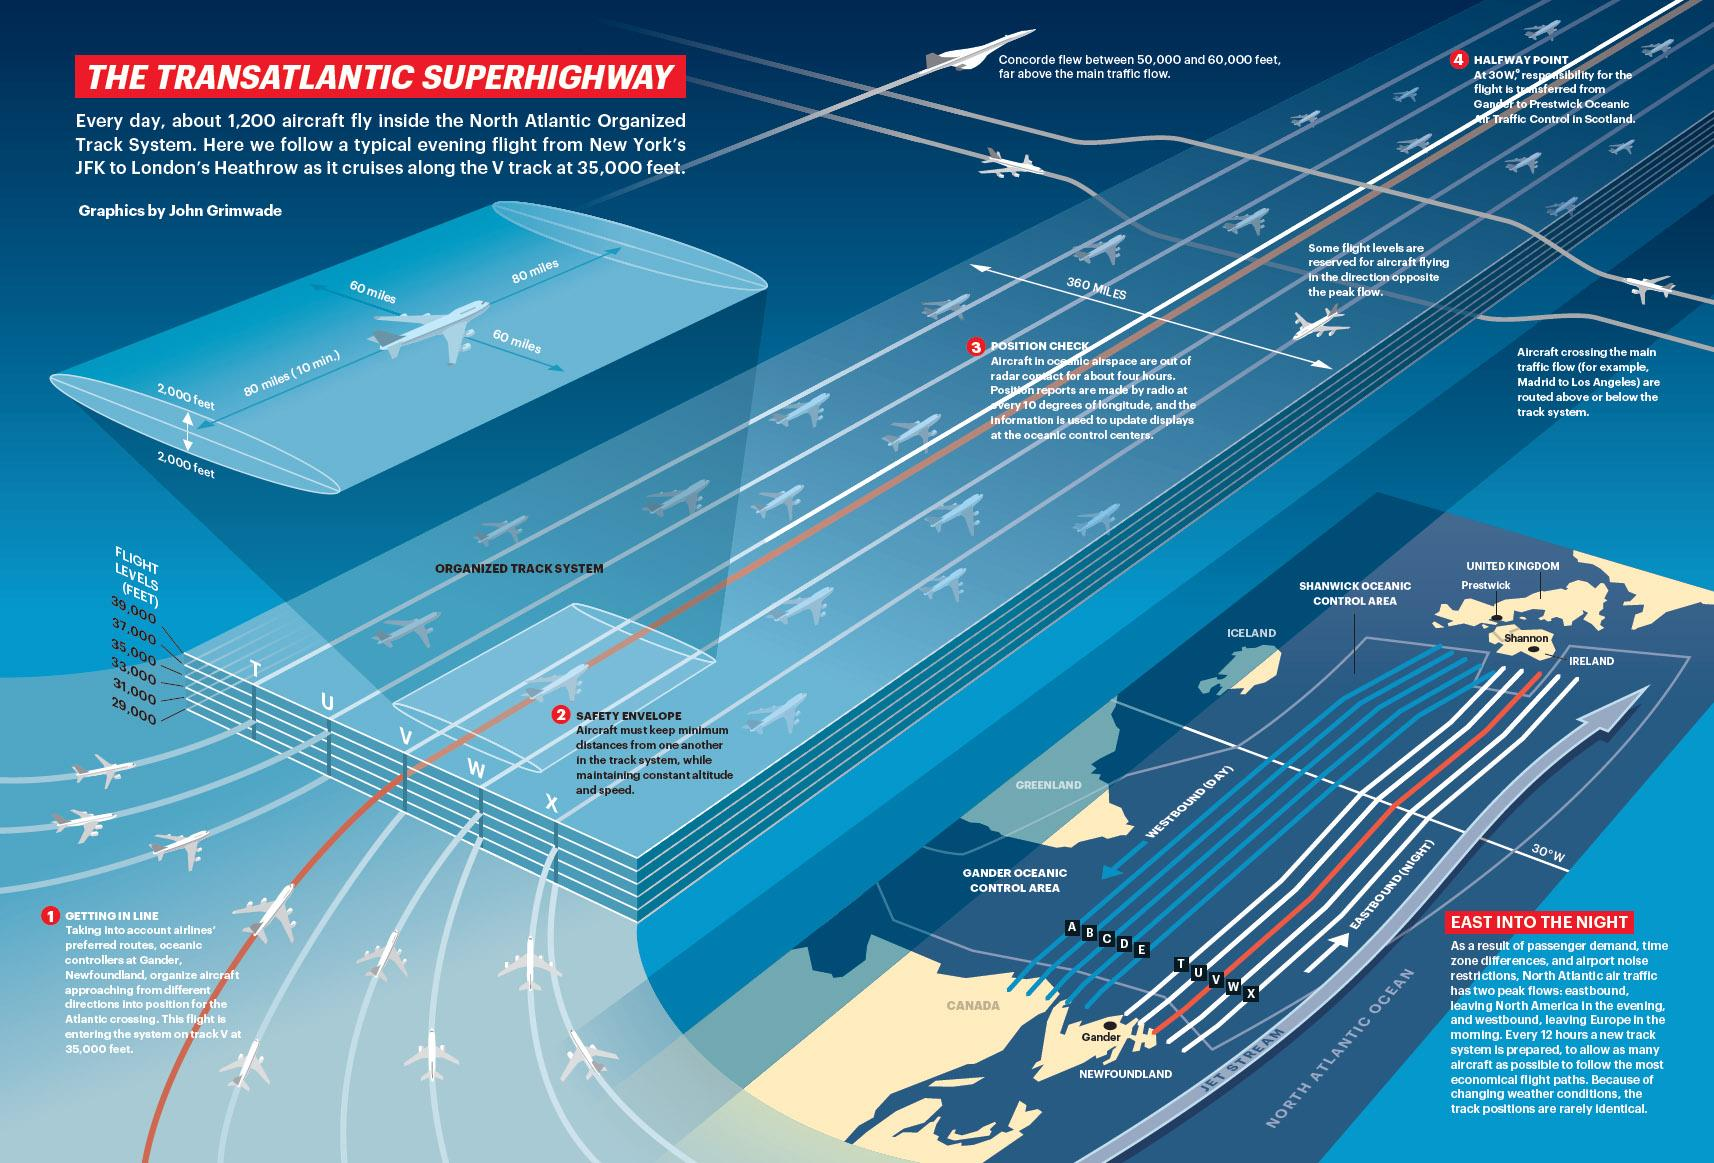Specify some key components in this picture. The Organized Track System has a breadth of 360 miles, as stated in the accompanying infographic. 